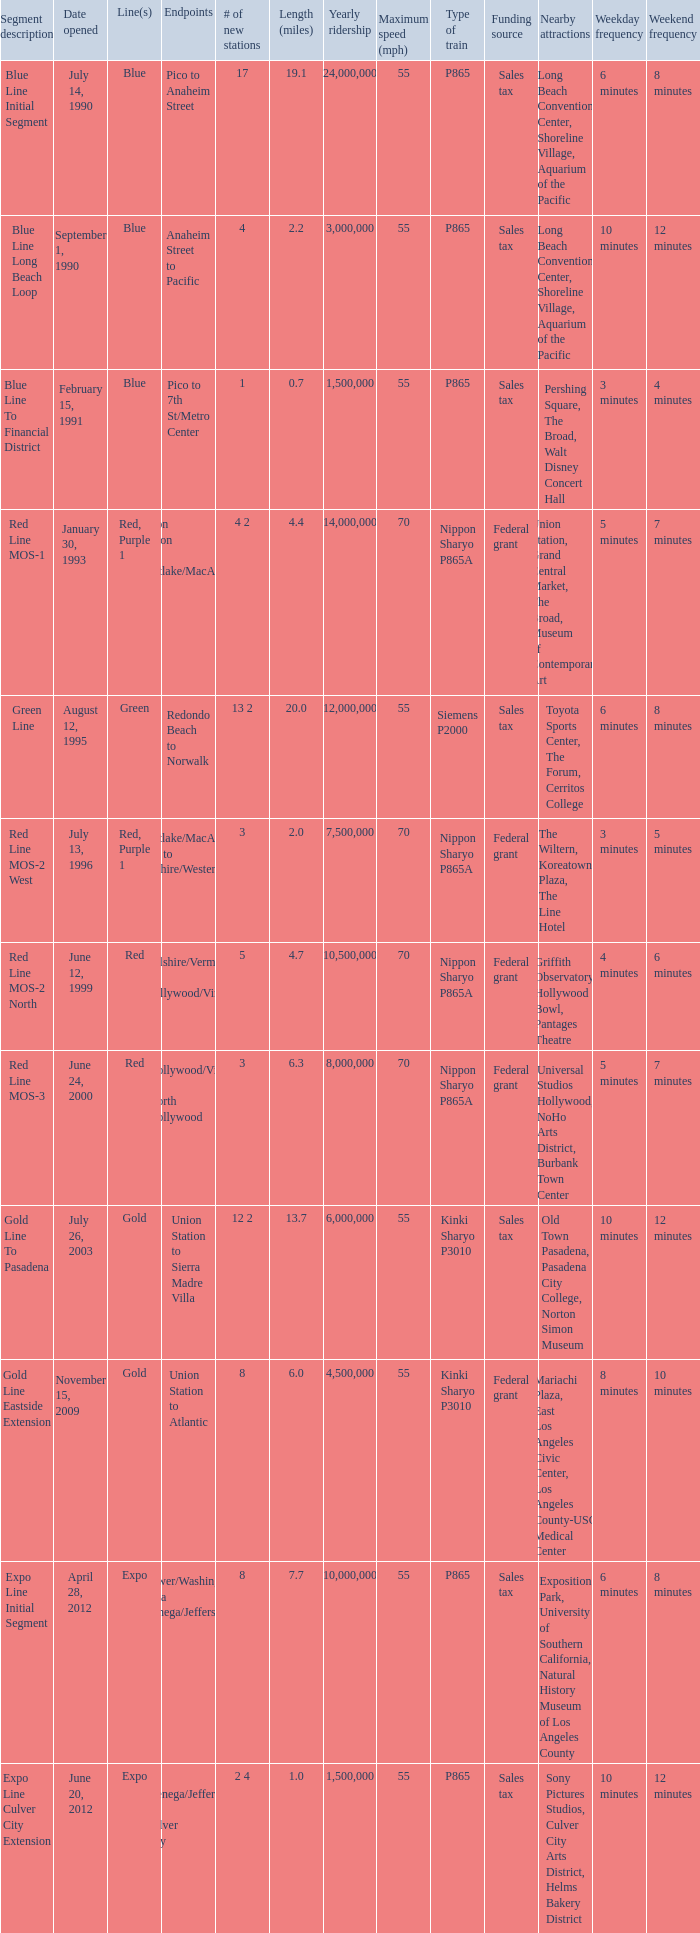What is the lenth (miles) of endpoints westlake/macarthur park to wilshire/western? 2.0. 